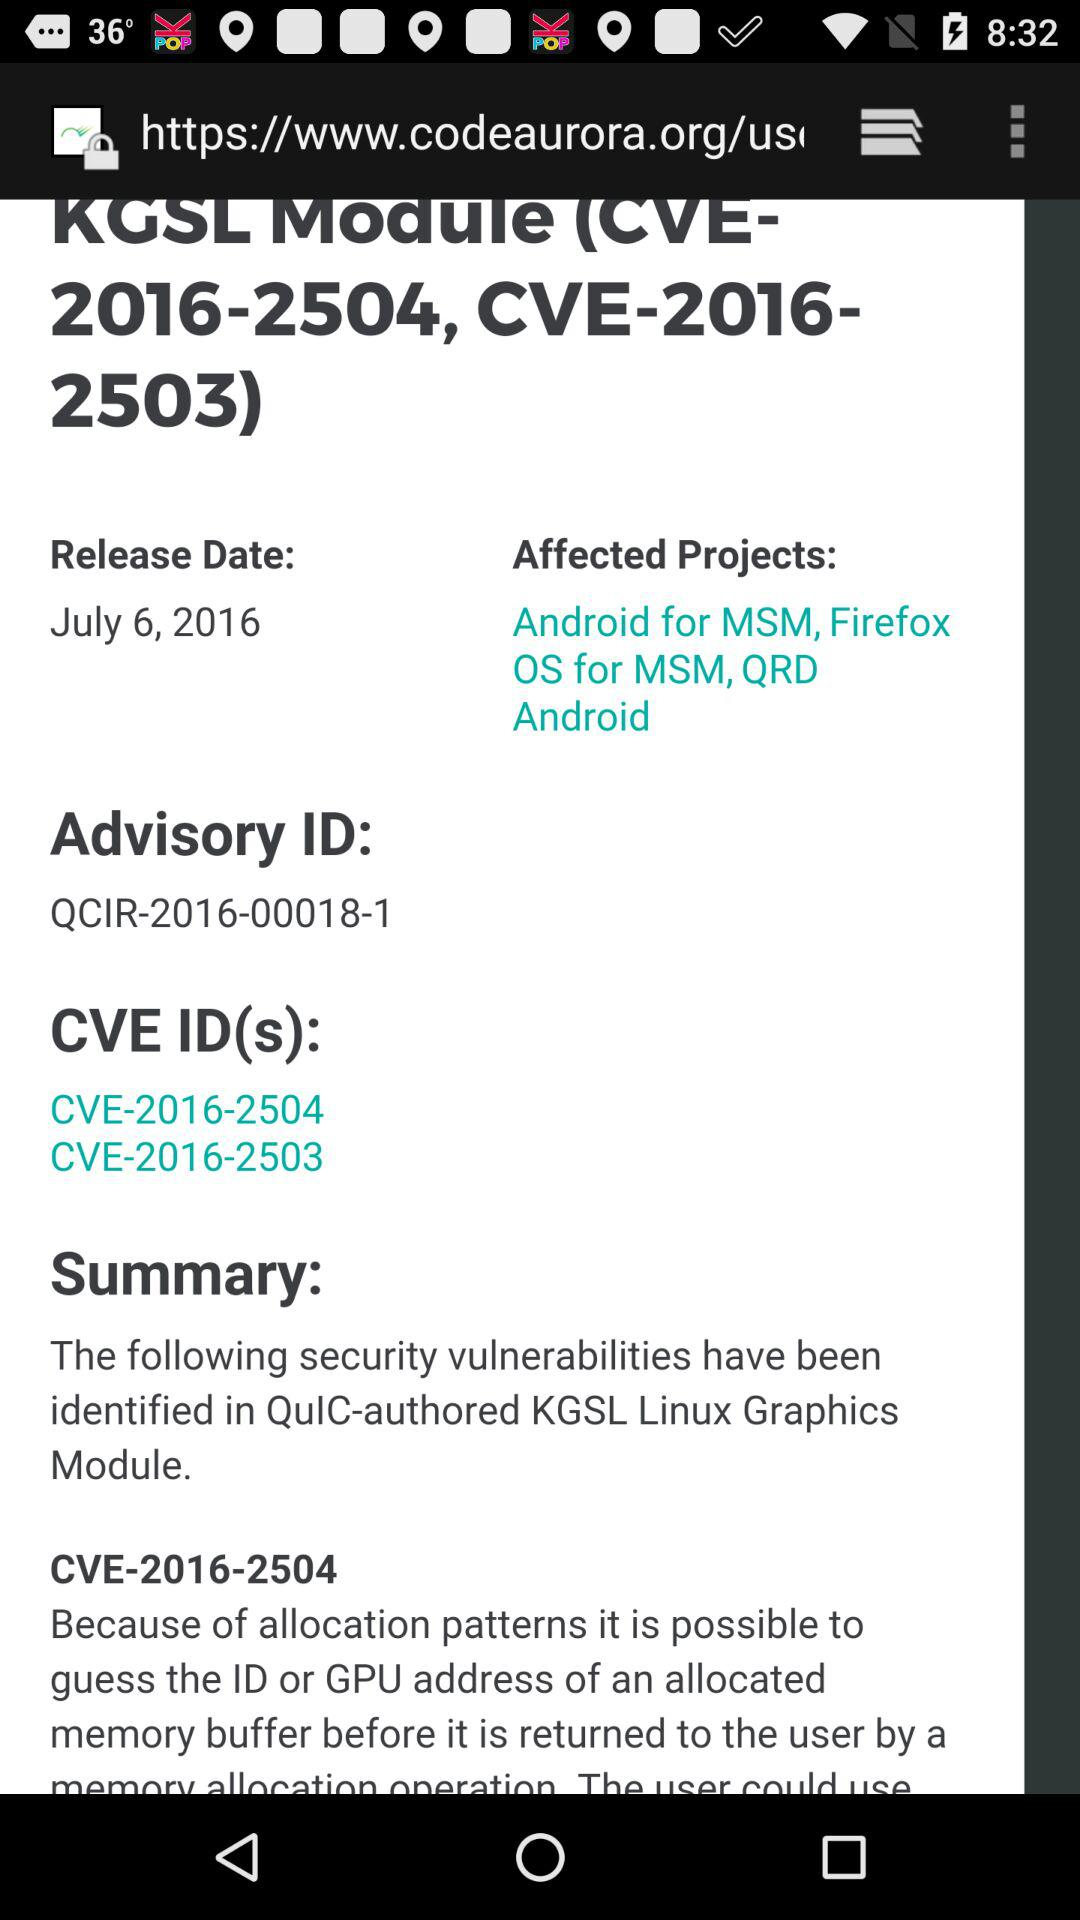What is the name of the project? The name of the projects are "Android for MSM", "Firefox OS for MSM" and "QRD Android". 